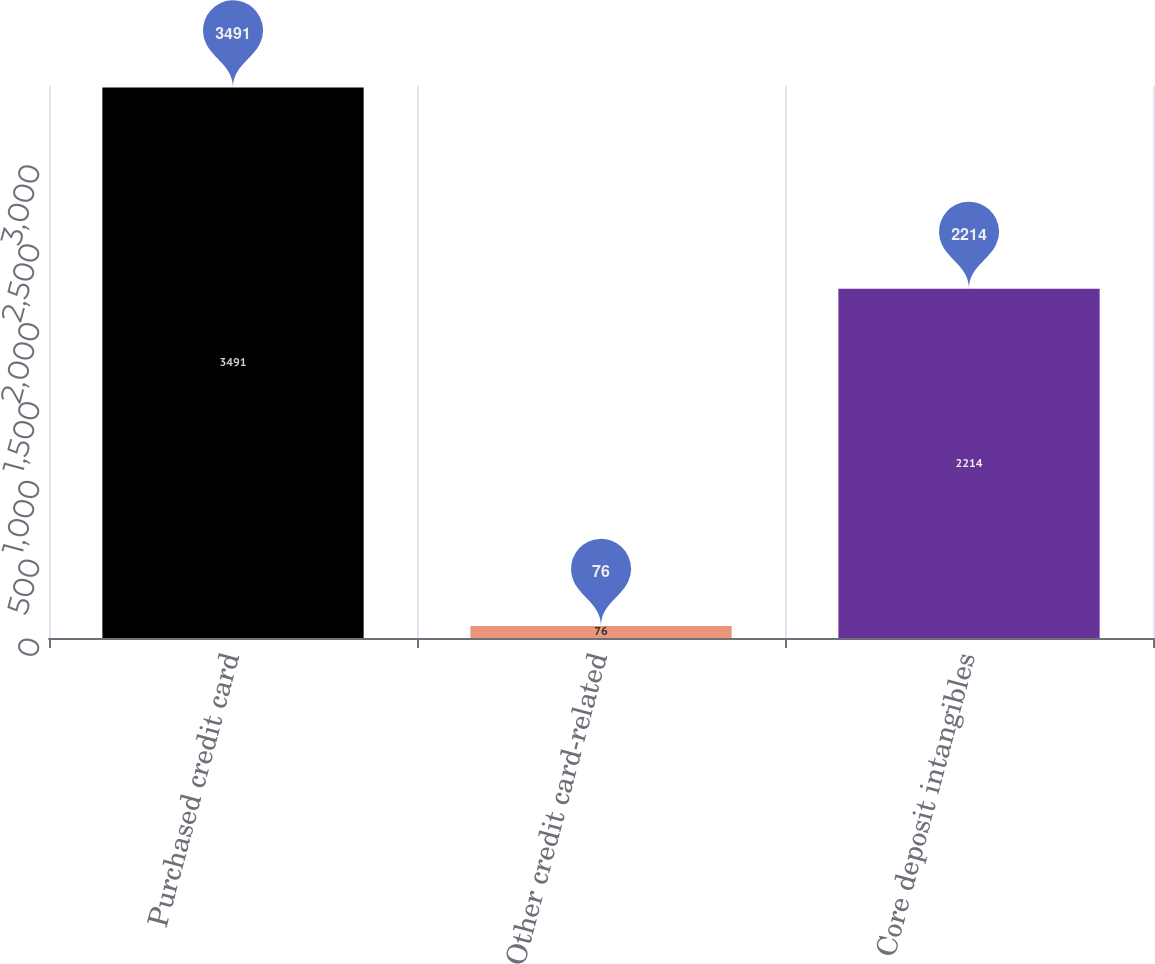<chart> <loc_0><loc_0><loc_500><loc_500><bar_chart><fcel>Purchased credit card<fcel>Other credit card-related<fcel>Core deposit intangibles<nl><fcel>3491<fcel>76<fcel>2214<nl></chart> 